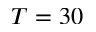Convert formula to latex. <formula><loc_0><loc_0><loc_500><loc_500>T = 3 0</formula> 